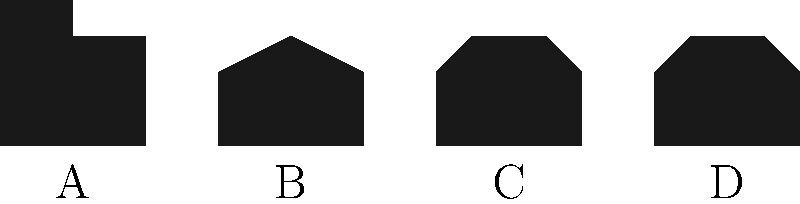Can you match these silhouettes to their historical figures? Which one represents Abraham Lincoln? Let's look at each silhouette and think about what we know about these historical figures:

1. Silhouette A: This shows a tall hat with a flat top. This is the iconic "stovepipe" hat that Abraham Lincoln was known for wearing. He was one of the tallest U.S. presidents and often wore this hat, making him even taller!

2. Silhouette B: This shows a distinctive two-cornered hat, also known as a bicorne. This was famously worn by Napoleon Bonaparte, the French military leader and emperor.

3. Silhouette C: This silhouette shows a large, elaborate headdress or crown. This likely represents Queen Elizabeth I of England, who was known for her ornate ruffs and headpieces.

4. Silhouette D: This silhouette shows a sleek hairstyle with what appears to be a band or crown. This could represent Cleopatra, the last active ruler of the Ptolemaic Kingdom of Egypt, who was often depicted wearing a diadem or crown.

Based on these observations, we can conclude that Abraham Lincoln is represented by Silhouette A.
Answer: A 